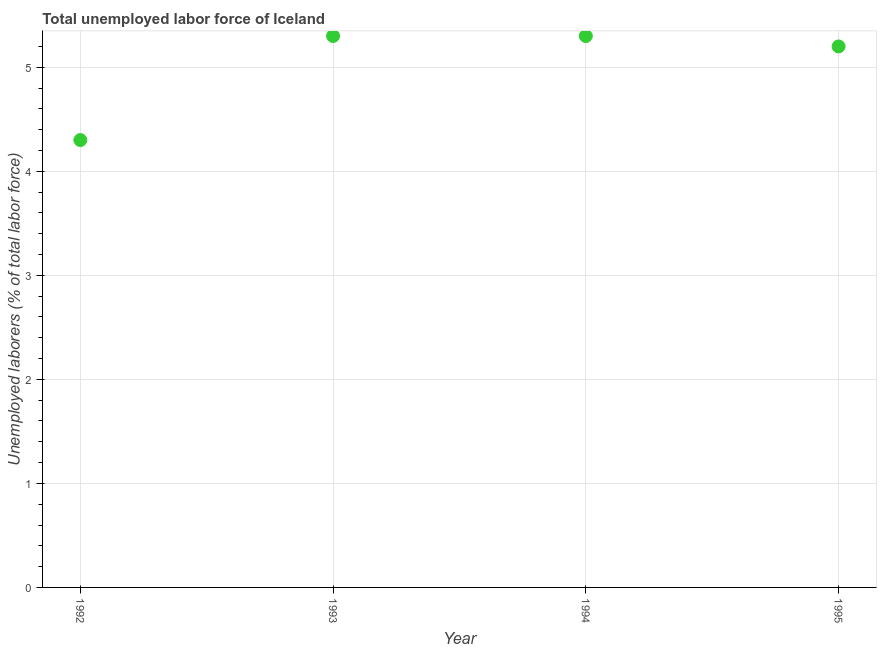What is the total unemployed labour force in 1995?
Provide a short and direct response. 5.2. Across all years, what is the maximum total unemployed labour force?
Make the answer very short. 5.3. Across all years, what is the minimum total unemployed labour force?
Offer a very short reply. 4.3. What is the sum of the total unemployed labour force?
Your response must be concise. 20.1. What is the difference between the total unemployed labour force in 1992 and 1995?
Offer a terse response. -0.9. What is the average total unemployed labour force per year?
Ensure brevity in your answer.  5.03. What is the median total unemployed labour force?
Give a very brief answer. 5.25. What is the ratio of the total unemployed labour force in 1992 to that in 1994?
Offer a very short reply. 0.81. What is the difference between the highest and the second highest total unemployed labour force?
Offer a very short reply. 0. Is the sum of the total unemployed labour force in 1993 and 1994 greater than the maximum total unemployed labour force across all years?
Offer a terse response. Yes. What is the difference between the highest and the lowest total unemployed labour force?
Keep it short and to the point. 1. How many years are there in the graph?
Your response must be concise. 4. Are the values on the major ticks of Y-axis written in scientific E-notation?
Ensure brevity in your answer.  No. Does the graph contain grids?
Your answer should be very brief. Yes. What is the title of the graph?
Offer a terse response. Total unemployed labor force of Iceland. What is the label or title of the Y-axis?
Provide a succinct answer. Unemployed laborers (% of total labor force). What is the Unemployed laborers (% of total labor force) in 1992?
Give a very brief answer. 4.3. What is the Unemployed laborers (% of total labor force) in 1993?
Your answer should be very brief. 5.3. What is the Unemployed laborers (% of total labor force) in 1994?
Offer a very short reply. 5.3. What is the Unemployed laborers (% of total labor force) in 1995?
Offer a terse response. 5.2. What is the difference between the Unemployed laborers (% of total labor force) in 1993 and 1994?
Your response must be concise. 0. What is the difference between the Unemployed laborers (% of total labor force) in 1993 and 1995?
Ensure brevity in your answer.  0.1. What is the ratio of the Unemployed laborers (% of total labor force) in 1992 to that in 1993?
Offer a very short reply. 0.81. What is the ratio of the Unemployed laborers (% of total labor force) in 1992 to that in 1994?
Provide a succinct answer. 0.81. What is the ratio of the Unemployed laborers (% of total labor force) in 1992 to that in 1995?
Offer a very short reply. 0.83. 